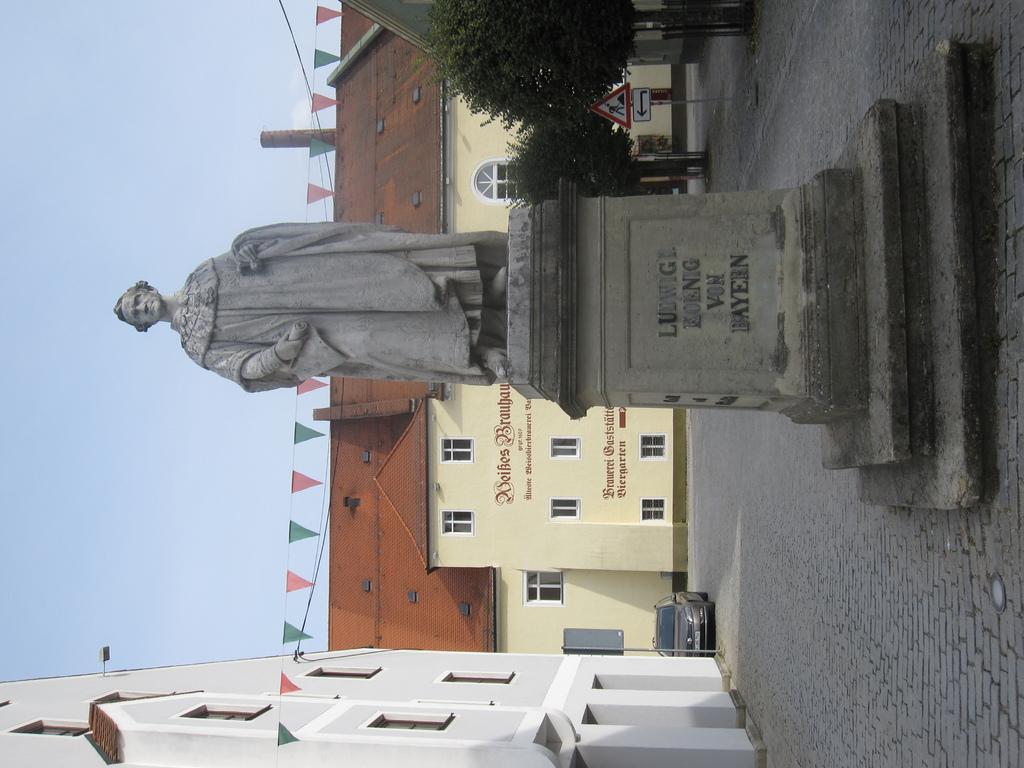How would you summarize this image in a sentence or two? In the middle of the picture, we see the statue. At the bottom, we see the building in white color. Beside that, we see a pole and a car parked on the road. At the top, we see trees and a board in white and red color. Behind the statue, we see a building in white color with a brown color roof. We even see the flags in green and red color. On the left side, we see the sky 